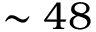<formula> <loc_0><loc_0><loc_500><loc_500>\sim 4 8</formula> 